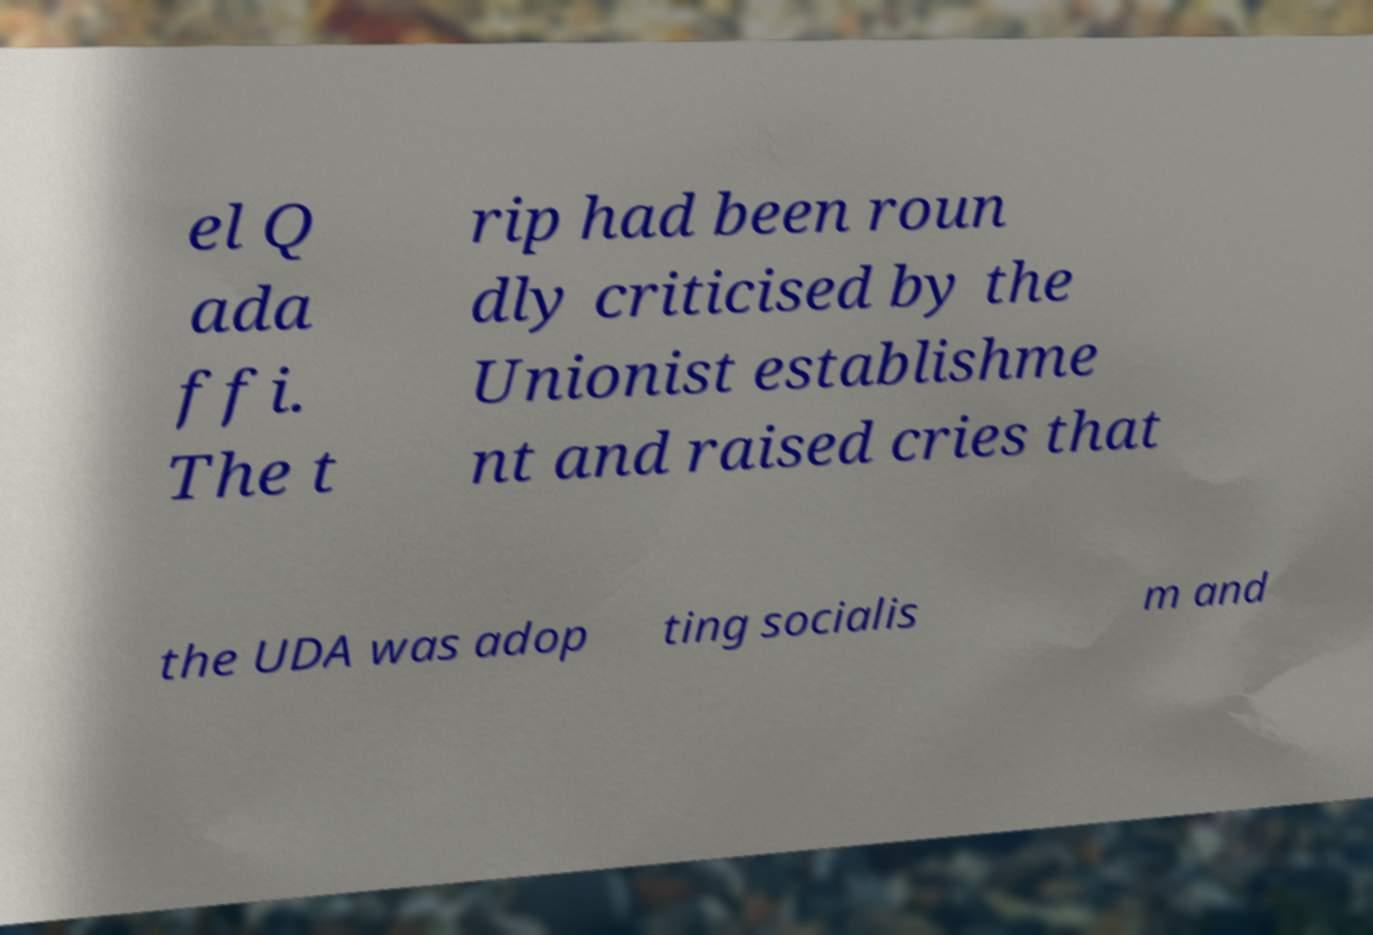What messages or text are displayed in this image? I need them in a readable, typed format. el Q ada ffi. The t rip had been roun dly criticised by the Unionist establishme nt and raised cries that the UDA was adop ting socialis m and 